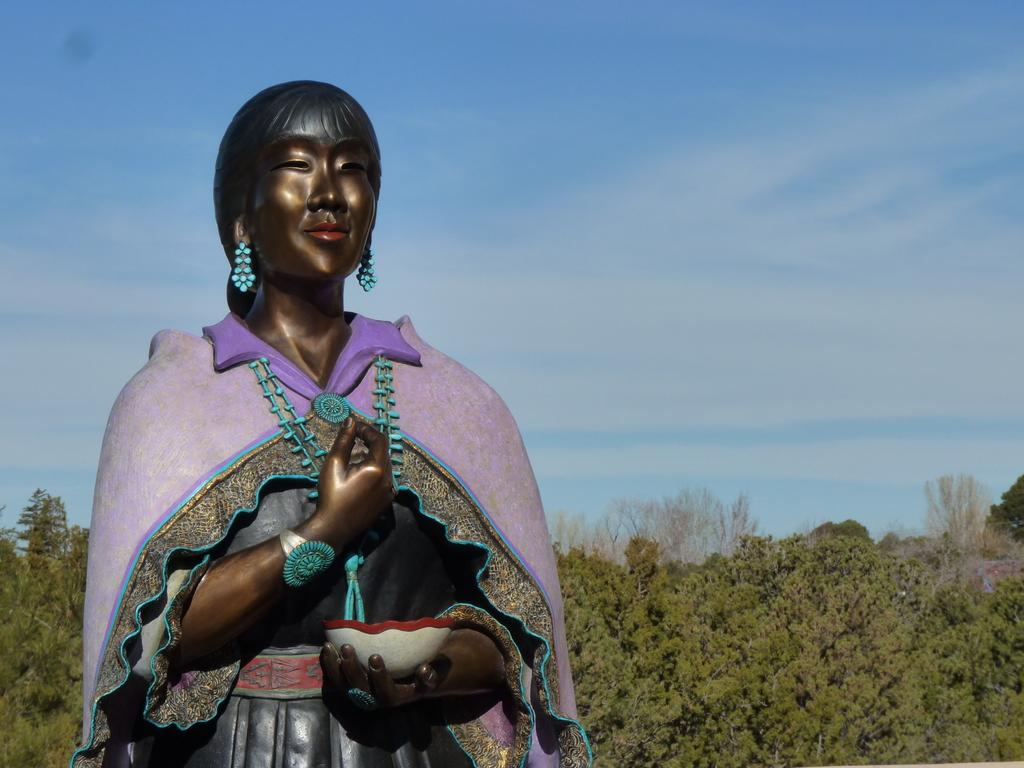What is the main subject of the image? There is a lady sculpture in the image. What is the lady sculpture holding? The lady sculpture is holding a bowl. What can be seen in the background of the image? There are trees visible in the image. What type of ink is being used by the lady sculpture to write a joke on the sponge in the image? There is no ink, joke, or sponge present in the image; it features a lady sculpture holding a bowl with trees in the background. 